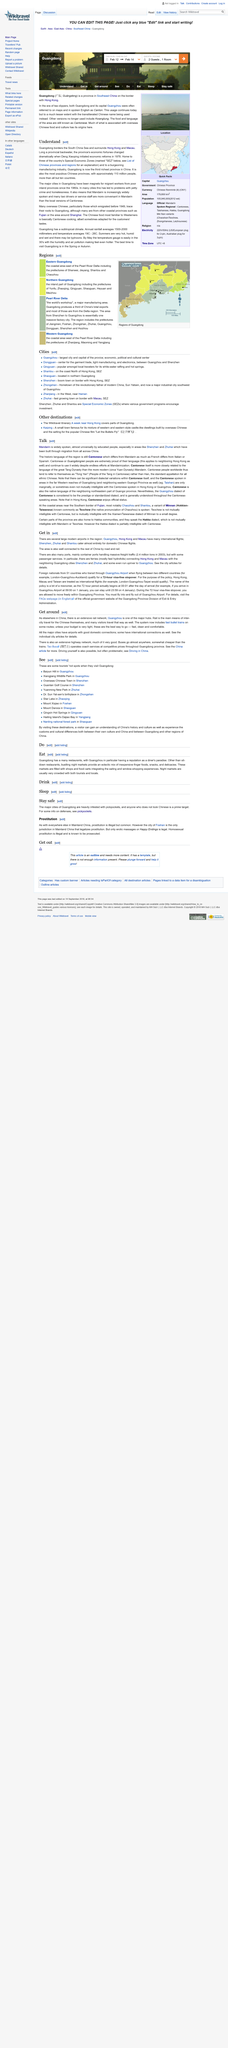Highlight a few significant elements in this photo. Shenzhen, Zhuhai, and Shantou primarily serve domestic Chinese flights and very few international flights. Many international flights originate from cities such as Guangzhou, Hong Kong, and Macau. Yes, there are multiple airports and ports in the region. 